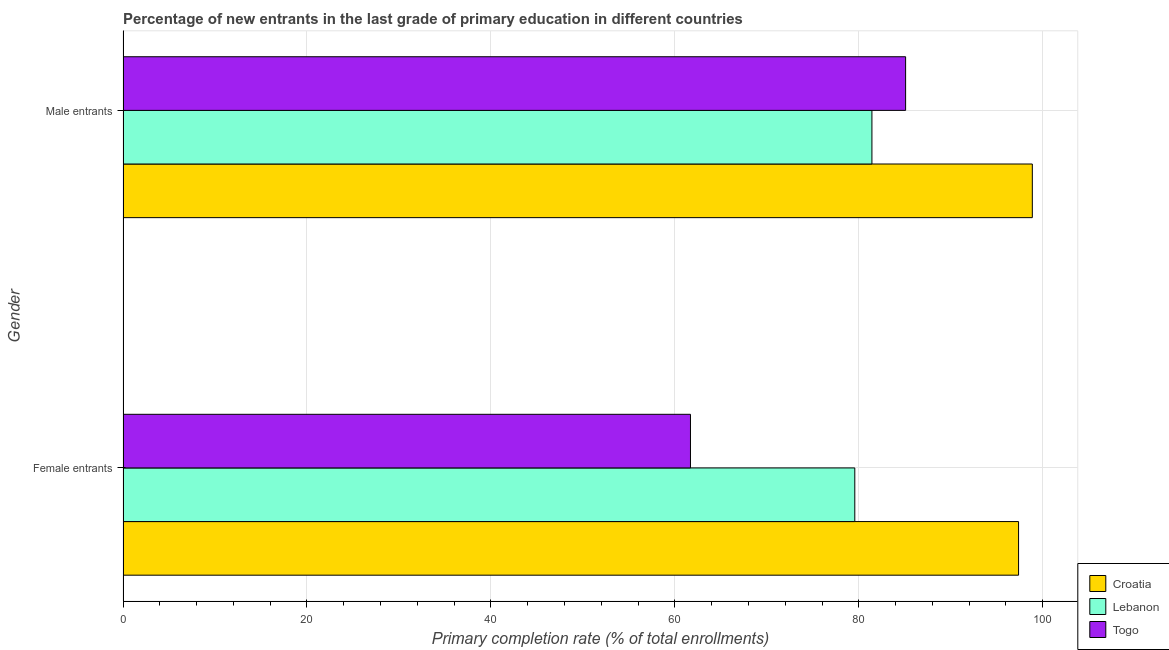Are the number of bars on each tick of the Y-axis equal?
Make the answer very short. Yes. How many bars are there on the 1st tick from the bottom?
Provide a succinct answer. 3. What is the label of the 2nd group of bars from the top?
Make the answer very short. Female entrants. What is the primary completion rate of female entrants in Lebanon?
Keep it short and to the point. 79.56. Across all countries, what is the maximum primary completion rate of male entrants?
Provide a succinct answer. 98.86. Across all countries, what is the minimum primary completion rate of female entrants?
Make the answer very short. 61.7. In which country was the primary completion rate of female entrants maximum?
Keep it short and to the point. Croatia. In which country was the primary completion rate of female entrants minimum?
Make the answer very short. Togo. What is the total primary completion rate of male entrants in the graph?
Provide a succinct answer. 265.37. What is the difference between the primary completion rate of male entrants in Lebanon and that in Togo?
Give a very brief answer. -3.66. What is the difference between the primary completion rate of male entrants in Lebanon and the primary completion rate of female entrants in Croatia?
Give a very brief answer. -15.94. What is the average primary completion rate of male entrants per country?
Provide a short and direct response. 88.46. What is the difference between the primary completion rate of female entrants and primary completion rate of male entrants in Lebanon?
Offer a very short reply. -1.86. In how many countries, is the primary completion rate of male entrants greater than 40 %?
Provide a succinct answer. 3. What is the ratio of the primary completion rate of male entrants in Togo to that in Lebanon?
Ensure brevity in your answer.  1.04. Is the primary completion rate of female entrants in Croatia less than that in Lebanon?
Provide a succinct answer. No. In how many countries, is the primary completion rate of male entrants greater than the average primary completion rate of male entrants taken over all countries?
Ensure brevity in your answer.  1. What does the 3rd bar from the top in Female entrants represents?
Give a very brief answer. Croatia. What does the 3rd bar from the bottom in Female entrants represents?
Your answer should be very brief. Togo. Are all the bars in the graph horizontal?
Offer a very short reply. Yes. What is the difference between two consecutive major ticks on the X-axis?
Your answer should be very brief. 20. Are the values on the major ticks of X-axis written in scientific E-notation?
Make the answer very short. No. Does the graph contain any zero values?
Provide a succinct answer. No. How many legend labels are there?
Offer a terse response. 3. How are the legend labels stacked?
Your answer should be very brief. Vertical. What is the title of the graph?
Keep it short and to the point. Percentage of new entrants in the last grade of primary education in different countries. Does "Greece" appear as one of the legend labels in the graph?
Your answer should be compact. No. What is the label or title of the X-axis?
Your answer should be compact. Primary completion rate (% of total enrollments). What is the Primary completion rate (% of total enrollments) in Croatia in Female entrants?
Offer a terse response. 97.37. What is the Primary completion rate (% of total enrollments) of Lebanon in Female entrants?
Offer a very short reply. 79.56. What is the Primary completion rate (% of total enrollments) of Togo in Female entrants?
Offer a very short reply. 61.7. What is the Primary completion rate (% of total enrollments) of Croatia in Male entrants?
Make the answer very short. 98.86. What is the Primary completion rate (% of total enrollments) in Lebanon in Male entrants?
Ensure brevity in your answer.  81.42. What is the Primary completion rate (% of total enrollments) of Togo in Male entrants?
Make the answer very short. 85.09. Across all Gender, what is the maximum Primary completion rate (% of total enrollments) of Croatia?
Keep it short and to the point. 98.86. Across all Gender, what is the maximum Primary completion rate (% of total enrollments) of Lebanon?
Your answer should be very brief. 81.42. Across all Gender, what is the maximum Primary completion rate (% of total enrollments) in Togo?
Offer a terse response. 85.09. Across all Gender, what is the minimum Primary completion rate (% of total enrollments) in Croatia?
Provide a short and direct response. 97.37. Across all Gender, what is the minimum Primary completion rate (% of total enrollments) in Lebanon?
Provide a succinct answer. 79.56. Across all Gender, what is the minimum Primary completion rate (% of total enrollments) in Togo?
Your answer should be compact. 61.7. What is the total Primary completion rate (% of total enrollments) in Croatia in the graph?
Offer a terse response. 196.23. What is the total Primary completion rate (% of total enrollments) of Lebanon in the graph?
Keep it short and to the point. 160.99. What is the total Primary completion rate (% of total enrollments) in Togo in the graph?
Provide a short and direct response. 146.78. What is the difference between the Primary completion rate (% of total enrollments) in Croatia in Female entrants and that in Male entrants?
Give a very brief answer. -1.5. What is the difference between the Primary completion rate (% of total enrollments) in Lebanon in Female entrants and that in Male entrants?
Offer a terse response. -1.86. What is the difference between the Primary completion rate (% of total enrollments) of Togo in Female entrants and that in Male entrants?
Offer a very short reply. -23.39. What is the difference between the Primary completion rate (% of total enrollments) in Croatia in Female entrants and the Primary completion rate (% of total enrollments) in Lebanon in Male entrants?
Provide a succinct answer. 15.94. What is the difference between the Primary completion rate (% of total enrollments) in Croatia in Female entrants and the Primary completion rate (% of total enrollments) in Togo in Male entrants?
Make the answer very short. 12.28. What is the difference between the Primary completion rate (% of total enrollments) in Lebanon in Female entrants and the Primary completion rate (% of total enrollments) in Togo in Male entrants?
Give a very brief answer. -5.52. What is the average Primary completion rate (% of total enrollments) of Croatia per Gender?
Your answer should be very brief. 98.11. What is the average Primary completion rate (% of total enrollments) in Lebanon per Gender?
Ensure brevity in your answer.  80.49. What is the average Primary completion rate (% of total enrollments) in Togo per Gender?
Give a very brief answer. 73.39. What is the difference between the Primary completion rate (% of total enrollments) of Croatia and Primary completion rate (% of total enrollments) of Lebanon in Female entrants?
Ensure brevity in your answer.  17.8. What is the difference between the Primary completion rate (% of total enrollments) of Croatia and Primary completion rate (% of total enrollments) of Togo in Female entrants?
Offer a very short reply. 35.67. What is the difference between the Primary completion rate (% of total enrollments) in Lebanon and Primary completion rate (% of total enrollments) in Togo in Female entrants?
Ensure brevity in your answer.  17.87. What is the difference between the Primary completion rate (% of total enrollments) of Croatia and Primary completion rate (% of total enrollments) of Lebanon in Male entrants?
Your response must be concise. 17.44. What is the difference between the Primary completion rate (% of total enrollments) in Croatia and Primary completion rate (% of total enrollments) in Togo in Male entrants?
Offer a very short reply. 13.78. What is the difference between the Primary completion rate (% of total enrollments) of Lebanon and Primary completion rate (% of total enrollments) of Togo in Male entrants?
Your answer should be compact. -3.66. What is the ratio of the Primary completion rate (% of total enrollments) in Croatia in Female entrants to that in Male entrants?
Provide a succinct answer. 0.98. What is the ratio of the Primary completion rate (% of total enrollments) of Lebanon in Female entrants to that in Male entrants?
Keep it short and to the point. 0.98. What is the ratio of the Primary completion rate (% of total enrollments) of Togo in Female entrants to that in Male entrants?
Provide a succinct answer. 0.73. What is the difference between the highest and the second highest Primary completion rate (% of total enrollments) of Croatia?
Your answer should be compact. 1.5. What is the difference between the highest and the second highest Primary completion rate (% of total enrollments) of Lebanon?
Your answer should be compact. 1.86. What is the difference between the highest and the second highest Primary completion rate (% of total enrollments) in Togo?
Offer a terse response. 23.39. What is the difference between the highest and the lowest Primary completion rate (% of total enrollments) in Croatia?
Offer a very short reply. 1.5. What is the difference between the highest and the lowest Primary completion rate (% of total enrollments) of Lebanon?
Make the answer very short. 1.86. What is the difference between the highest and the lowest Primary completion rate (% of total enrollments) in Togo?
Provide a short and direct response. 23.39. 